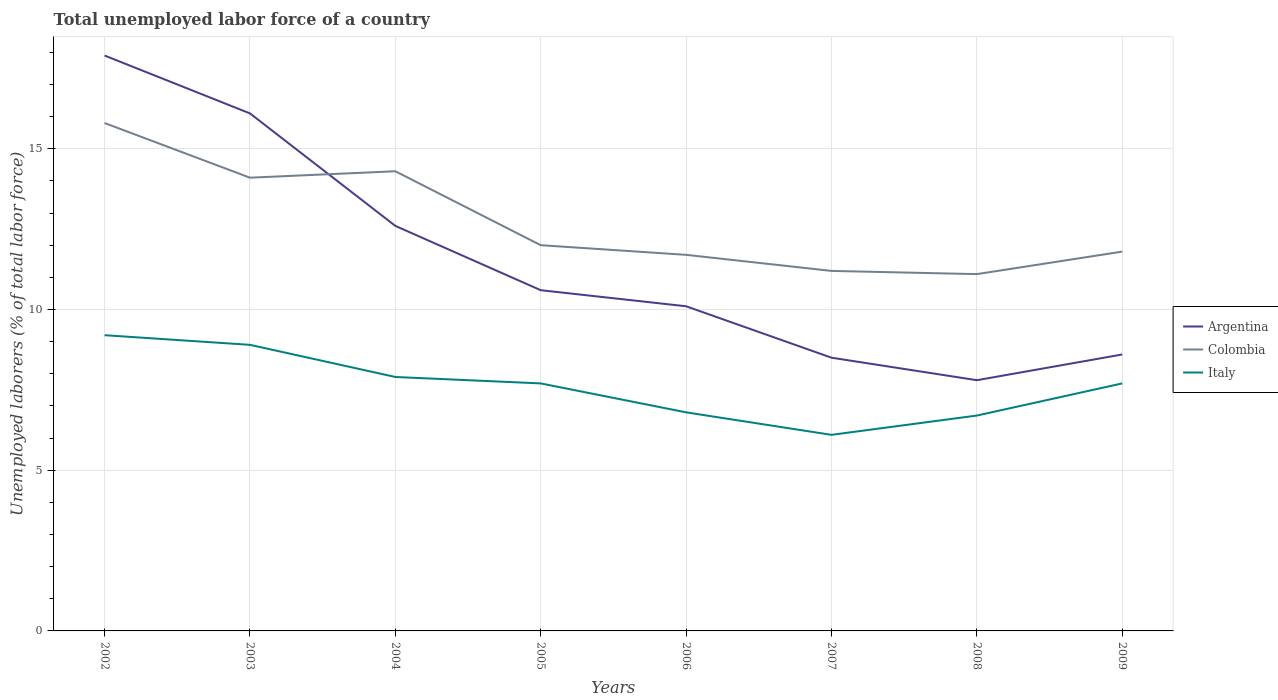Is the number of lines equal to the number of legend labels?
Provide a short and direct response. Yes. Across all years, what is the maximum total unemployed labor force in Colombia?
Your answer should be compact. 11.1. In which year was the total unemployed labor force in Italy maximum?
Offer a terse response. 2007. What is the total total unemployed labor force in Colombia in the graph?
Ensure brevity in your answer.  4.6. What is the difference between the highest and the second highest total unemployed labor force in Colombia?
Make the answer very short. 4.7. What is the difference between the highest and the lowest total unemployed labor force in Colombia?
Make the answer very short. 3. Is the total unemployed labor force in Italy strictly greater than the total unemployed labor force in Colombia over the years?
Give a very brief answer. Yes. How many lines are there?
Your answer should be compact. 3. How many years are there in the graph?
Your answer should be compact. 8. Are the values on the major ticks of Y-axis written in scientific E-notation?
Give a very brief answer. No. Does the graph contain any zero values?
Keep it short and to the point. No. Where does the legend appear in the graph?
Your response must be concise. Center right. How are the legend labels stacked?
Your answer should be compact. Vertical. What is the title of the graph?
Make the answer very short. Total unemployed labor force of a country. What is the label or title of the X-axis?
Your answer should be compact. Years. What is the label or title of the Y-axis?
Offer a very short reply. Unemployed laborers (% of total labor force). What is the Unemployed laborers (% of total labor force) of Argentina in 2002?
Ensure brevity in your answer.  17.9. What is the Unemployed laborers (% of total labor force) in Colombia in 2002?
Offer a terse response. 15.8. What is the Unemployed laborers (% of total labor force) in Italy in 2002?
Offer a terse response. 9.2. What is the Unemployed laborers (% of total labor force) of Argentina in 2003?
Provide a short and direct response. 16.1. What is the Unemployed laborers (% of total labor force) of Colombia in 2003?
Give a very brief answer. 14.1. What is the Unemployed laborers (% of total labor force) in Italy in 2003?
Make the answer very short. 8.9. What is the Unemployed laborers (% of total labor force) of Argentina in 2004?
Your answer should be compact. 12.6. What is the Unemployed laborers (% of total labor force) of Colombia in 2004?
Keep it short and to the point. 14.3. What is the Unemployed laborers (% of total labor force) of Italy in 2004?
Your answer should be compact. 7.9. What is the Unemployed laborers (% of total labor force) in Argentina in 2005?
Provide a succinct answer. 10.6. What is the Unemployed laborers (% of total labor force) in Italy in 2005?
Your answer should be compact. 7.7. What is the Unemployed laborers (% of total labor force) of Argentina in 2006?
Provide a short and direct response. 10.1. What is the Unemployed laborers (% of total labor force) of Colombia in 2006?
Your answer should be compact. 11.7. What is the Unemployed laborers (% of total labor force) in Italy in 2006?
Keep it short and to the point. 6.8. What is the Unemployed laborers (% of total labor force) in Argentina in 2007?
Offer a terse response. 8.5. What is the Unemployed laborers (% of total labor force) in Colombia in 2007?
Offer a very short reply. 11.2. What is the Unemployed laborers (% of total labor force) of Italy in 2007?
Your answer should be very brief. 6.1. What is the Unemployed laborers (% of total labor force) in Argentina in 2008?
Offer a terse response. 7.8. What is the Unemployed laborers (% of total labor force) in Colombia in 2008?
Provide a succinct answer. 11.1. What is the Unemployed laborers (% of total labor force) of Italy in 2008?
Make the answer very short. 6.7. What is the Unemployed laborers (% of total labor force) in Argentina in 2009?
Ensure brevity in your answer.  8.6. What is the Unemployed laborers (% of total labor force) of Colombia in 2009?
Your answer should be very brief. 11.8. What is the Unemployed laborers (% of total labor force) in Italy in 2009?
Ensure brevity in your answer.  7.7. Across all years, what is the maximum Unemployed laborers (% of total labor force) in Argentina?
Offer a very short reply. 17.9. Across all years, what is the maximum Unemployed laborers (% of total labor force) of Colombia?
Ensure brevity in your answer.  15.8. Across all years, what is the maximum Unemployed laborers (% of total labor force) of Italy?
Your answer should be compact. 9.2. Across all years, what is the minimum Unemployed laborers (% of total labor force) of Argentina?
Provide a succinct answer. 7.8. Across all years, what is the minimum Unemployed laborers (% of total labor force) of Colombia?
Give a very brief answer. 11.1. Across all years, what is the minimum Unemployed laborers (% of total labor force) in Italy?
Give a very brief answer. 6.1. What is the total Unemployed laborers (% of total labor force) in Argentina in the graph?
Your response must be concise. 92.2. What is the total Unemployed laborers (% of total labor force) in Colombia in the graph?
Your answer should be very brief. 102. What is the total Unemployed laborers (% of total labor force) of Italy in the graph?
Offer a terse response. 61. What is the difference between the Unemployed laborers (% of total labor force) of Colombia in 2002 and that in 2003?
Your answer should be very brief. 1.7. What is the difference between the Unemployed laborers (% of total labor force) of Argentina in 2002 and that in 2004?
Give a very brief answer. 5.3. What is the difference between the Unemployed laborers (% of total labor force) of Italy in 2002 and that in 2005?
Ensure brevity in your answer.  1.5. What is the difference between the Unemployed laborers (% of total labor force) in Argentina in 2002 and that in 2006?
Your answer should be compact. 7.8. What is the difference between the Unemployed laborers (% of total labor force) in Argentina in 2002 and that in 2007?
Provide a short and direct response. 9.4. What is the difference between the Unemployed laborers (% of total labor force) of Colombia in 2002 and that in 2008?
Provide a succinct answer. 4.7. What is the difference between the Unemployed laborers (% of total labor force) of Italy in 2002 and that in 2008?
Give a very brief answer. 2.5. What is the difference between the Unemployed laborers (% of total labor force) of Argentina in 2002 and that in 2009?
Keep it short and to the point. 9.3. What is the difference between the Unemployed laborers (% of total labor force) of Colombia in 2002 and that in 2009?
Make the answer very short. 4. What is the difference between the Unemployed laborers (% of total labor force) of Italy in 2003 and that in 2004?
Offer a terse response. 1. What is the difference between the Unemployed laborers (% of total labor force) in Argentina in 2003 and that in 2005?
Provide a succinct answer. 5.5. What is the difference between the Unemployed laborers (% of total labor force) of Colombia in 2003 and that in 2005?
Your answer should be very brief. 2.1. What is the difference between the Unemployed laborers (% of total labor force) of Colombia in 2003 and that in 2007?
Give a very brief answer. 2.9. What is the difference between the Unemployed laborers (% of total labor force) of Argentina in 2003 and that in 2008?
Your answer should be compact. 8.3. What is the difference between the Unemployed laborers (% of total labor force) in Colombia in 2003 and that in 2009?
Keep it short and to the point. 2.3. What is the difference between the Unemployed laborers (% of total labor force) in Italy in 2003 and that in 2009?
Offer a very short reply. 1.2. What is the difference between the Unemployed laborers (% of total labor force) of Argentina in 2004 and that in 2005?
Your answer should be compact. 2. What is the difference between the Unemployed laborers (% of total labor force) of Colombia in 2004 and that in 2005?
Make the answer very short. 2.3. What is the difference between the Unemployed laborers (% of total labor force) in Colombia in 2004 and that in 2006?
Keep it short and to the point. 2.6. What is the difference between the Unemployed laborers (% of total labor force) of Argentina in 2004 and that in 2007?
Offer a very short reply. 4.1. What is the difference between the Unemployed laborers (% of total labor force) of Colombia in 2004 and that in 2007?
Your answer should be very brief. 3.1. What is the difference between the Unemployed laborers (% of total labor force) in Italy in 2004 and that in 2007?
Your response must be concise. 1.8. What is the difference between the Unemployed laborers (% of total labor force) in Colombia in 2004 and that in 2008?
Provide a short and direct response. 3.2. What is the difference between the Unemployed laborers (% of total labor force) of Colombia in 2005 and that in 2007?
Ensure brevity in your answer.  0.8. What is the difference between the Unemployed laborers (% of total labor force) in Italy in 2005 and that in 2007?
Give a very brief answer. 1.6. What is the difference between the Unemployed laborers (% of total labor force) of Colombia in 2005 and that in 2008?
Keep it short and to the point. 0.9. What is the difference between the Unemployed laborers (% of total labor force) in Argentina in 2006 and that in 2008?
Offer a very short reply. 2.3. What is the difference between the Unemployed laborers (% of total labor force) in Italy in 2006 and that in 2008?
Your response must be concise. 0.1. What is the difference between the Unemployed laborers (% of total labor force) of Argentina in 2006 and that in 2009?
Provide a succinct answer. 1.5. What is the difference between the Unemployed laborers (% of total labor force) of Colombia in 2006 and that in 2009?
Keep it short and to the point. -0.1. What is the difference between the Unemployed laborers (% of total labor force) in Italy in 2006 and that in 2009?
Give a very brief answer. -0.9. What is the difference between the Unemployed laborers (% of total labor force) of Argentina in 2007 and that in 2008?
Offer a terse response. 0.7. What is the difference between the Unemployed laborers (% of total labor force) of Colombia in 2007 and that in 2008?
Keep it short and to the point. 0.1. What is the difference between the Unemployed laborers (% of total labor force) of Italy in 2007 and that in 2008?
Offer a terse response. -0.6. What is the difference between the Unemployed laborers (% of total labor force) of Italy in 2007 and that in 2009?
Give a very brief answer. -1.6. What is the difference between the Unemployed laborers (% of total labor force) of Colombia in 2008 and that in 2009?
Ensure brevity in your answer.  -0.7. What is the difference between the Unemployed laborers (% of total labor force) in Argentina in 2002 and the Unemployed laborers (% of total labor force) in Italy in 2003?
Your answer should be compact. 9. What is the difference between the Unemployed laborers (% of total labor force) in Argentina in 2002 and the Unemployed laborers (% of total labor force) in Italy in 2004?
Ensure brevity in your answer.  10. What is the difference between the Unemployed laborers (% of total labor force) in Colombia in 2002 and the Unemployed laborers (% of total labor force) in Italy in 2004?
Provide a succinct answer. 7.9. What is the difference between the Unemployed laborers (% of total labor force) in Argentina in 2002 and the Unemployed laborers (% of total labor force) in Colombia in 2006?
Offer a very short reply. 6.2. What is the difference between the Unemployed laborers (% of total labor force) of Argentina in 2002 and the Unemployed laborers (% of total labor force) of Italy in 2006?
Keep it short and to the point. 11.1. What is the difference between the Unemployed laborers (% of total labor force) of Colombia in 2002 and the Unemployed laborers (% of total labor force) of Italy in 2006?
Offer a very short reply. 9. What is the difference between the Unemployed laborers (% of total labor force) of Colombia in 2002 and the Unemployed laborers (% of total labor force) of Italy in 2007?
Keep it short and to the point. 9.7. What is the difference between the Unemployed laborers (% of total labor force) of Argentina in 2002 and the Unemployed laborers (% of total labor force) of Colombia in 2008?
Provide a succinct answer. 6.8. What is the difference between the Unemployed laborers (% of total labor force) of Argentina in 2002 and the Unemployed laborers (% of total labor force) of Italy in 2008?
Provide a succinct answer. 11.2. What is the difference between the Unemployed laborers (% of total labor force) of Argentina in 2003 and the Unemployed laborers (% of total labor force) of Colombia in 2004?
Make the answer very short. 1.8. What is the difference between the Unemployed laborers (% of total labor force) of Argentina in 2003 and the Unemployed laborers (% of total labor force) of Colombia in 2005?
Provide a short and direct response. 4.1. What is the difference between the Unemployed laborers (% of total labor force) of Argentina in 2003 and the Unemployed laborers (% of total labor force) of Colombia in 2006?
Offer a terse response. 4.4. What is the difference between the Unemployed laborers (% of total labor force) in Colombia in 2003 and the Unemployed laborers (% of total labor force) in Italy in 2006?
Your response must be concise. 7.3. What is the difference between the Unemployed laborers (% of total labor force) of Argentina in 2003 and the Unemployed laborers (% of total labor force) of Italy in 2007?
Provide a short and direct response. 10. What is the difference between the Unemployed laborers (% of total labor force) of Argentina in 2003 and the Unemployed laborers (% of total labor force) of Colombia in 2008?
Provide a short and direct response. 5. What is the difference between the Unemployed laborers (% of total labor force) of Argentina in 2003 and the Unemployed laborers (% of total labor force) of Colombia in 2009?
Your answer should be compact. 4.3. What is the difference between the Unemployed laborers (% of total labor force) in Argentina in 2003 and the Unemployed laborers (% of total labor force) in Italy in 2009?
Provide a succinct answer. 8.4. What is the difference between the Unemployed laborers (% of total labor force) of Colombia in 2003 and the Unemployed laborers (% of total labor force) of Italy in 2009?
Ensure brevity in your answer.  6.4. What is the difference between the Unemployed laborers (% of total labor force) of Argentina in 2004 and the Unemployed laborers (% of total labor force) of Colombia in 2005?
Keep it short and to the point. 0.6. What is the difference between the Unemployed laborers (% of total labor force) in Argentina in 2004 and the Unemployed laborers (% of total labor force) in Italy in 2005?
Provide a short and direct response. 4.9. What is the difference between the Unemployed laborers (% of total labor force) in Colombia in 2004 and the Unemployed laborers (% of total labor force) in Italy in 2005?
Offer a very short reply. 6.6. What is the difference between the Unemployed laborers (% of total labor force) in Argentina in 2004 and the Unemployed laborers (% of total labor force) in Italy in 2006?
Your answer should be compact. 5.8. What is the difference between the Unemployed laborers (% of total labor force) in Argentina in 2004 and the Unemployed laborers (% of total labor force) in Italy in 2007?
Offer a very short reply. 6.5. What is the difference between the Unemployed laborers (% of total labor force) of Argentina in 2004 and the Unemployed laborers (% of total labor force) of Colombia in 2008?
Your answer should be compact. 1.5. What is the difference between the Unemployed laborers (% of total labor force) of Colombia in 2004 and the Unemployed laborers (% of total labor force) of Italy in 2008?
Your answer should be compact. 7.6. What is the difference between the Unemployed laborers (% of total labor force) in Argentina in 2004 and the Unemployed laborers (% of total labor force) in Colombia in 2009?
Offer a very short reply. 0.8. What is the difference between the Unemployed laborers (% of total labor force) in Argentina in 2005 and the Unemployed laborers (% of total labor force) in Colombia in 2006?
Offer a very short reply. -1.1. What is the difference between the Unemployed laborers (% of total labor force) of Argentina in 2005 and the Unemployed laborers (% of total labor force) of Italy in 2006?
Your answer should be very brief. 3.8. What is the difference between the Unemployed laborers (% of total labor force) of Colombia in 2005 and the Unemployed laborers (% of total labor force) of Italy in 2006?
Your answer should be compact. 5.2. What is the difference between the Unemployed laborers (% of total labor force) of Argentina in 2005 and the Unemployed laborers (% of total labor force) of Colombia in 2007?
Give a very brief answer. -0.6. What is the difference between the Unemployed laborers (% of total labor force) of Argentina in 2005 and the Unemployed laborers (% of total labor force) of Italy in 2007?
Give a very brief answer. 4.5. What is the difference between the Unemployed laborers (% of total labor force) of Colombia in 2005 and the Unemployed laborers (% of total labor force) of Italy in 2007?
Ensure brevity in your answer.  5.9. What is the difference between the Unemployed laborers (% of total labor force) in Argentina in 2005 and the Unemployed laborers (% of total labor force) in Italy in 2008?
Make the answer very short. 3.9. What is the difference between the Unemployed laborers (% of total labor force) of Colombia in 2005 and the Unemployed laborers (% of total labor force) of Italy in 2008?
Offer a very short reply. 5.3. What is the difference between the Unemployed laborers (% of total labor force) in Argentina in 2005 and the Unemployed laborers (% of total labor force) in Colombia in 2009?
Your answer should be very brief. -1.2. What is the difference between the Unemployed laborers (% of total labor force) of Argentina in 2005 and the Unemployed laborers (% of total labor force) of Italy in 2009?
Provide a short and direct response. 2.9. What is the difference between the Unemployed laborers (% of total labor force) of Argentina in 2006 and the Unemployed laborers (% of total labor force) of Colombia in 2007?
Provide a succinct answer. -1.1. What is the difference between the Unemployed laborers (% of total labor force) of Colombia in 2006 and the Unemployed laborers (% of total labor force) of Italy in 2007?
Provide a succinct answer. 5.6. What is the difference between the Unemployed laborers (% of total labor force) in Argentina in 2006 and the Unemployed laborers (% of total labor force) in Colombia in 2008?
Offer a very short reply. -1. What is the difference between the Unemployed laborers (% of total labor force) of Argentina in 2006 and the Unemployed laborers (% of total labor force) of Italy in 2008?
Ensure brevity in your answer.  3.4. What is the difference between the Unemployed laborers (% of total labor force) of Colombia in 2006 and the Unemployed laborers (% of total labor force) of Italy in 2008?
Your response must be concise. 5. What is the difference between the Unemployed laborers (% of total labor force) of Argentina in 2006 and the Unemployed laborers (% of total labor force) of Colombia in 2009?
Offer a very short reply. -1.7. What is the difference between the Unemployed laborers (% of total labor force) in Colombia in 2006 and the Unemployed laborers (% of total labor force) in Italy in 2009?
Give a very brief answer. 4. What is the difference between the Unemployed laborers (% of total labor force) in Argentina in 2007 and the Unemployed laborers (% of total labor force) in Italy in 2008?
Ensure brevity in your answer.  1.8. What is the difference between the Unemployed laborers (% of total labor force) of Argentina in 2007 and the Unemployed laborers (% of total labor force) of Colombia in 2009?
Keep it short and to the point. -3.3. What is the difference between the Unemployed laborers (% of total labor force) in Argentina in 2007 and the Unemployed laborers (% of total labor force) in Italy in 2009?
Your answer should be compact. 0.8. What is the difference between the Unemployed laborers (% of total labor force) of Argentina in 2008 and the Unemployed laborers (% of total labor force) of Italy in 2009?
Ensure brevity in your answer.  0.1. What is the difference between the Unemployed laborers (% of total labor force) of Colombia in 2008 and the Unemployed laborers (% of total labor force) of Italy in 2009?
Offer a very short reply. 3.4. What is the average Unemployed laborers (% of total labor force) of Argentina per year?
Your answer should be compact. 11.53. What is the average Unemployed laborers (% of total labor force) of Colombia per year?
Give a very brief answer. 12.75. What is the average Unemployed laborers (% of total labor force) of Italy per year?
Provide a short and direct response. 7.62. In the year 2002, what is the difference between the Unemployed laborers (% of total labor force) of Argentina and Unemployed laborers (% of total labor force) of Colombia?
Offer a terse response. 2.1. In the year 2002, what is the difference between the Unemployed laborers (% of total labor force) in Argentina and Unemployed laborers (% of total labor force) in Italy?
Your answer should be compact. 8.7. In the year 2003, what is the difference between the Unemployed laborers (% of total labor force) in Argentina and Unemployed laborers (% of total labor force) in Colombia?
Offer a very short reply. 2. In the year 2003, what is the difference between the Unemployed laborers (% of total labor force) of Colombia and Unemployed laborers (% of total labor force) of Italy?
Ensure brevity in your answer.  5.2. In the year 2004, what is the difference between the Unemployed laborers (% of total labor force) of Argentina and Unemployed laborers (% of total labor force) of Italy?
Ensure brevity in your answer.  4.7. In the year 2004, what is the difference between the Unemployed laborers (% of total labor force) in Colombia and Unemployed laborers (% of total labor force) in Italy?
Give a very brief answer. 6.4. In the year 2006, what is the difference between the Unemployed laborers (% of total labor force) in Argentina and Unemployed laborers (% of total labor force) in Colombia?
Ensure brevity in your answer.  -1.6. In the year 2006, what is the difference between the Unemployed laborers (% of total labor force) in Argentina and Unemployed laborers (% of total labor force) in Italy?
Keep it short and to the point. 3.3. In the year 2006, what is the difference between the Unemployed laborers (% of total labor force) in Colombia and Unemployed laborers (% of total labor force) in Italy?
Your response must be concise. 4.9. In the year 2007, what is the difference between the Unemployed laborers (% of total labor force) of Colombia and Unemployed laborers (% of total labor force) of Italy?
Your response must be concise. 5.1. In the year 2008, what is the difference between the Unemployed laborers (% of total labor force) of Argentina and Unemployed laborers (% of total labor force) of Italy?
Offer a very short reply. 1.1. What is the ratio of the Unemployed laborers (% of total labor force) of Argentina in 2002 to that in 2003?
Provide a succinct answer. 1.11. What is the ratio of the Unemployed laborers (% of total labor force) in Colombia in 2002 to that in 2003?
Your answer should be very brief. 1.12. What is the ratio of the Unemployed laborers (% of total labor force) of Italy in 2002 to that in 2003?
Provide a short and direct response. 1.03. What is the ratio of the Unemployed laborers (% of total labor force) in Argentina in 2002 to that in 2004?
Provide a succinct answer. 1.42. What is the ratio of the Unemployed laborers (% of total labor force) of Colombia in 2002 to that in 2004?
Your response must be concise. 1.1. What is the ratio of the Unemployed laborers (% of total labor force) of Italy in 2002 to that in 2004?
Your answer should be compact. 1.16. What is the ratio of the Unemployed laborers (% of total labor force) in Argentina in 2002 to that in 2005?
Ensure brevity in your answer.  1.69. What is the ratio of the Unemployed laborers (% of total labor force) in Colombia in 2002 to that in 2005?
Give a very brief answer. 1.32. What is the ratio of the Unemployed laborers (% of total labor force) of Italy in 2002 to that in 2005?
Your answer should be very brief. 1.19. What is the ratio of the Unemployed laborers (% of total labor force) of Argentina in 2002 to that in 2006?
Your response must be concise. 1.77. What is the ratio of the Unemployed laborers (% of total labor force) in Colombia in 2002 to that in 2006?
Your answer should be very brief. 1.35. What is the ratio of the Unemployed laborers (% of total labor force) in Italy in 2002 to that in 2006?
Offer a terse response. 1.35. What is the ratio of the Unemployed laborers (% of total labor force) of Argentina in 2002 to that in 2007?
Provide a succinct answer. 2.11. What is the ratio of the Unemployed laborers (% of total labor force) of Colombia in 2002 to that in 2007?
Provide a short and direct response. 1.41. What is the ratio of the Unemployed laborers (% of total labor force) in Italy in 2002 to that in 2007?
Provide a short and direct response. 1.51. What is the ratio of the Unemployed laborers (% of total labor force) in Argentina in 2002 to that in 2008?
Keep it short and to the point. 2.29. What is the ratio of the Unemployed laborers (% of total labor force) in Colombia in 2002 to that in 2008?
Ensure brevity in your answer.  1.42. What is the ratio of the Unemployed laborers (% of total labor force) in Italy in 2002 to that in 2008?
Offer a very short reply. 1.37. What is the ratio of the Unemployed laborers (% of total labor force) in Argentina in 2002 to that in 2009?
Provide a succinct answer. 2.08. What is the ratio of the Unemployed laborers (% of total labor force) in Colombia in 2002 to that in 2009?
Offer a terse response. 1.34. What is the ratio of the Unemployed laborers (% of total labor force) in Italy in 2002 to that in 2009?
Give a very brief answer. 1.19. What is the ratio of the Unemployed laborers (% of total labor force) in Argentina in 2003 to that in 2004?
Make the answer very short. 1.28. What is the ratio of the Unemployed laborers (% of total labor force) of Italy in 2003 to that in 2004?
Your answer should be very brief. 1.13. What is the ratio of the Unemployed laborers (% of total labor force) in Argentina in 2003 to that in 2005?
Provide a short and direct response. 1.52. What is the ratio of the Unemployed laborers (% of total labor force) of Colombia in 2003 to that in 2005?
Make the answer very short. 1.18. What is the ratio of the Unemployed laborers (% of total labor force) of Italy in 2003 to that in 2005?
Your answer should be compact. 1.16. What is the ratio of the Unemployed laborers (% of total labor force) of Argentina in 2003 to that in 2006?
Your answer should be very brief. 1.59. What is the ratio of the Unemployed laborers (% of total labor force) of Colombia in 2003 to that in 2006?
Your answer should be compact. 1.21. What is the ratio of the Unemployed laborers (% of total labor force) in Italy in 2003 to that in 2006?
Your answer should be compact. 1.31. What is the ratio of the Unemployed laborers (% of total labor force) of Argentina in 2003 to that in 2007?
Keep it short and to the point. 1.89. What is the ratio of the Unemployed laborers (% of total labor force) in Colombia in 2003 to that in 2007?
Offer a very short reply. 1.26. What is the ratio of the Unemployed laborers (% of total labor force) in Italy in 2003 to that in 2007?
Ensure brevity in your answer.  1.46. What is the ratio of the Unemployed laborers (% of total labor force) of Argentina in 2003 to that in 2008?
Ensure brevity in your answer.  2.06. What is the ratio of the Unemployed laborers (% of total labor force) in Colombia in 2003 to that in 2008?
Your response must be concise. 1.27. What is the ratio of the Unemployed laborers (% of total labor force) of Italy in 2003 to that in 2008?
Your response must be concise. 1.33. What is the ratio of the Unemployed laborers (% of total labor force) of Argentina in 2003 to that in 2009?
Your answer should be compact. 1.87. What is the ratio of the Unemployed laborers (% of total labor force) in Colombia in 2003 to that in 2009?
Your response must be concise. 1.19. What is the ratio of the Unemployed laborers (% of total labor force) in Italy in 2003 to that in 2009?
Your answer should be very brief. 1.16. What is the ratio of the Unemployed laborers (% of total labor force) in Argentina in 2004 to that in 2005?
Your answer should be compact. 1.19. What is the ratio of the Unemployed laborers (% of total labor force) in Colombia in 2004 to that in 2005?
Offer a terse response. 1.19. What is the ratio of the Unemployed laborers (% of total labor force) of Italy in 2004 to that in 2005?
Provide a succinct answer. 1.03. What is the ratio of the Unemployed laborers (% of total labor force) in Argentina in 2004 to that in 2006?
Give a very brief answer. 1.25. What is the ratio of the Unemployed laborers (% of total labor force) in Colombia in 2004 to that in 2006?
Your answer should be very brief. 1.22. What is the ratio of the Unemployed laborers (% of total labor force) in Italy in 2004 to that in 2006?
Your response must be concise. 1.16. What is the ratio of the Unemployed laborers (% of total labor force) of Argentina in 2004 to that in 2007?
Keep it short and to the point. 1.48. What is the ratio of the Unemployed laborers (% of total labor force) of Colombia in 2004 to that in 2007?
Your answer should be very brief. 1.28. What is the ratio of the Unemployed laborers (% of total labor force) of Italy in 2004 to that in 2007?
Provide a short and direct response. 1.3. What is the ratio of the Unemployed laborers (% of total labor force) of Argentina in 2004 to that in 2008?
Provide a succinct answer. 1.62. What is the ratio of the Unemployed laborers (% of total labor force) of Colombia in 2004 to that in 2008?
Your response must be concise. 1.29. What is the ratio of the Unemployed laborers (% of total labor force) of Italy in 2004 to that in 2008?
Offer a terse response. 1.18. What is the ratio of the Unemployed laborers (% of total labor force) in Argentina in 2004 to that in 2009?
Ensure brevity in your answer.  1.47. What is the ratio of the Unemployed laborers (% of total labor force) of Colombia in 2004 to that in 2009?
Keep it short and to the point. 1.21. What is the ratio of the Unemployed laborers (% of total labor force) of Italy in 2004 to that in 2009?
Offer a very short reply. 1.03. What is the ratio of the Unemployed laborers (% of total labor force) in Argentina in 2005 to that in 2006?
Your answer should be very brief. 1.05. What is the ratio of the Unemployed laborers (% of total labor force) of Colombia in 2005 to that in 2006?
Your response must be concise. 1.03. What is the ratio of the Unemployed laborers (% of total labor force) of Italy in 2005 to that in 2006?
Keep it short and to the point. 1.13. What is the ratio of the Unemployed laborers (% of total labor force) of Argentina in 2005 to that in 2007?
Give a very brief answer. 1.25. What is the ratio of the Unemployed laborers (% of total labor force) in Colombia in 2005 to that in 2007?
Your response must be concise. 1.07. What is the ratio of the Unemployed laborers (% of total labor force) of Italy in 2005 to that in 2007?
Make the answer very short. 1.26. What is the ratio of the Unemployed laborers (% of total labor force) of Argentina in 2005 to that in 2008?
Provide a short and direct response. 1.36. What is the ratio of the Unemployed laborers (% of total labor force) in Colombia in 2005 to that in 2008?
Ensure brevity in your answer.  1.08. What is the ratio of the Unemployed laborers (% of total labor force) of Italy in 2005 to that in 2008?
Give a very brief answer. 1.15. What is the ratio of the Unemployed laborers (% of total labor force) of Argentina in 2005 to that in 2009?
Make the answer very short. 1.23. What is the ratio of the Unemployed laborers (% of total labor force) of Colombia in 2005 to that in 2009?
Offer a very short reply. 1.02. What is the ratio of the Unemployed laborers (% of total labor force) in Italy in 2005 to that in 2009?
Offer a terse response. 1. What is the ratio of the Unemployed laborers (% of total labor force) of Argentina in 2006 to that in 2007?
Provide a short and direct response. 1.19. What is the ratio of the Unemployed laborers (% of total labor force) of Colombia in 2006 to that in 2007?
Make the answer very short. 1.04. What is the ratio of the Unemployed laborers (% of total labor force) in Italy in 2006 to that in 2007?
Your response must be concise. 1.11. What is the ratio of the Unemployed laborers (% of total labor force) of Argentina in 2006 to that in 2008?
Provide a succinct answer. 1.29. What is the ratio of the Unemployed laborers (% of total labor force) in Colombia in 2006 to that in 2008?
Provide a succinct answer. 1.05. What is the ratio of the Unemployed laborers (% of total labor force) in Italy in 2006 to that in 2008?
Your response must be concise. 1.01. What is the ratio of the Unemployed laborers (% of total labor force) of Argentina in 2006 to that in 2009?
Keep it short and to the point. 1.17. What is the ratio of the Unemployed laborers (% of total labor force) of Colombia in 2006 to that in 2009?
Provide a short and direct response. 0.99. What is the ratio of the Unemployed laborers (% of total labor force) in Italy in 2006 to that in 2009?
Your answer should be very brief. 0.88. What is the ratio of the Unemployed laborers (% of total labor force) of Argentina in 2007 to that in 2008?
Ensure brevity in your answer.  1.09. What is the ratio of the Unemployed laborers (% of total labor force) of Colombia in 2007 to that in 2008?
Provide a short and direct response. 1.01. What is the ratio of the Unemployed laborers (% of total labor force) in Italy in 2007 to that in 2008?
Offer a terse response. 0.91. What is the ratio of the Unemployed laborers (% of total labor force) of Argentina in 2007 to that in 2009?
Offer a terse response. 0.99. What is the ratio of the Unemployed laborers (% of total labor force) in Colombia in 2007 to that in 2009?
Keep it short and to the point. 0.95. What is the ratio of the Unemployed laborers (% of total labor force) of Italy in 2007 to that in 2009?
Your answer should be compact. 0.79. What is the ratio of the Unemployed laborers (% of total labor force) in Argentina in 2008 to that in 2009?
Offer a terse response. 0.91. What is the ratio of the Unemployed laborers (% of total labor force) of Colombia in 2008 to that in 2009?
Your answer should be compact. 0.94. What is the ratio of the Unemployed laborers (% of total labor force) of Italy in 2008 to that in 2009?
Ensure brevity in your answer.  0.87. What is the difference between the highest and the second highest Unemployed laborers (% of total labor force) in Argentina?
Ensure brevity in your answer.  1.8. What is the difference between the highest and the second highest Unemployed laborers (% of total labor force) in Colombia?
Keep it short and to the point. 1.5. What is the difference between the highest and the lowest Unemployed laborers (% of total labor force) in Argentina?
Your answer should be compact. 10.1. What is the difference between the highest and the lowest Unemployed laborers (% of total labor force) of Colombia?
Provide a short and direct response. 4.7. What is the difference between the highest and the lowest Unemployed laborers (% of total labor force) of Italy?
Provide a short and direct response. 3.1. 